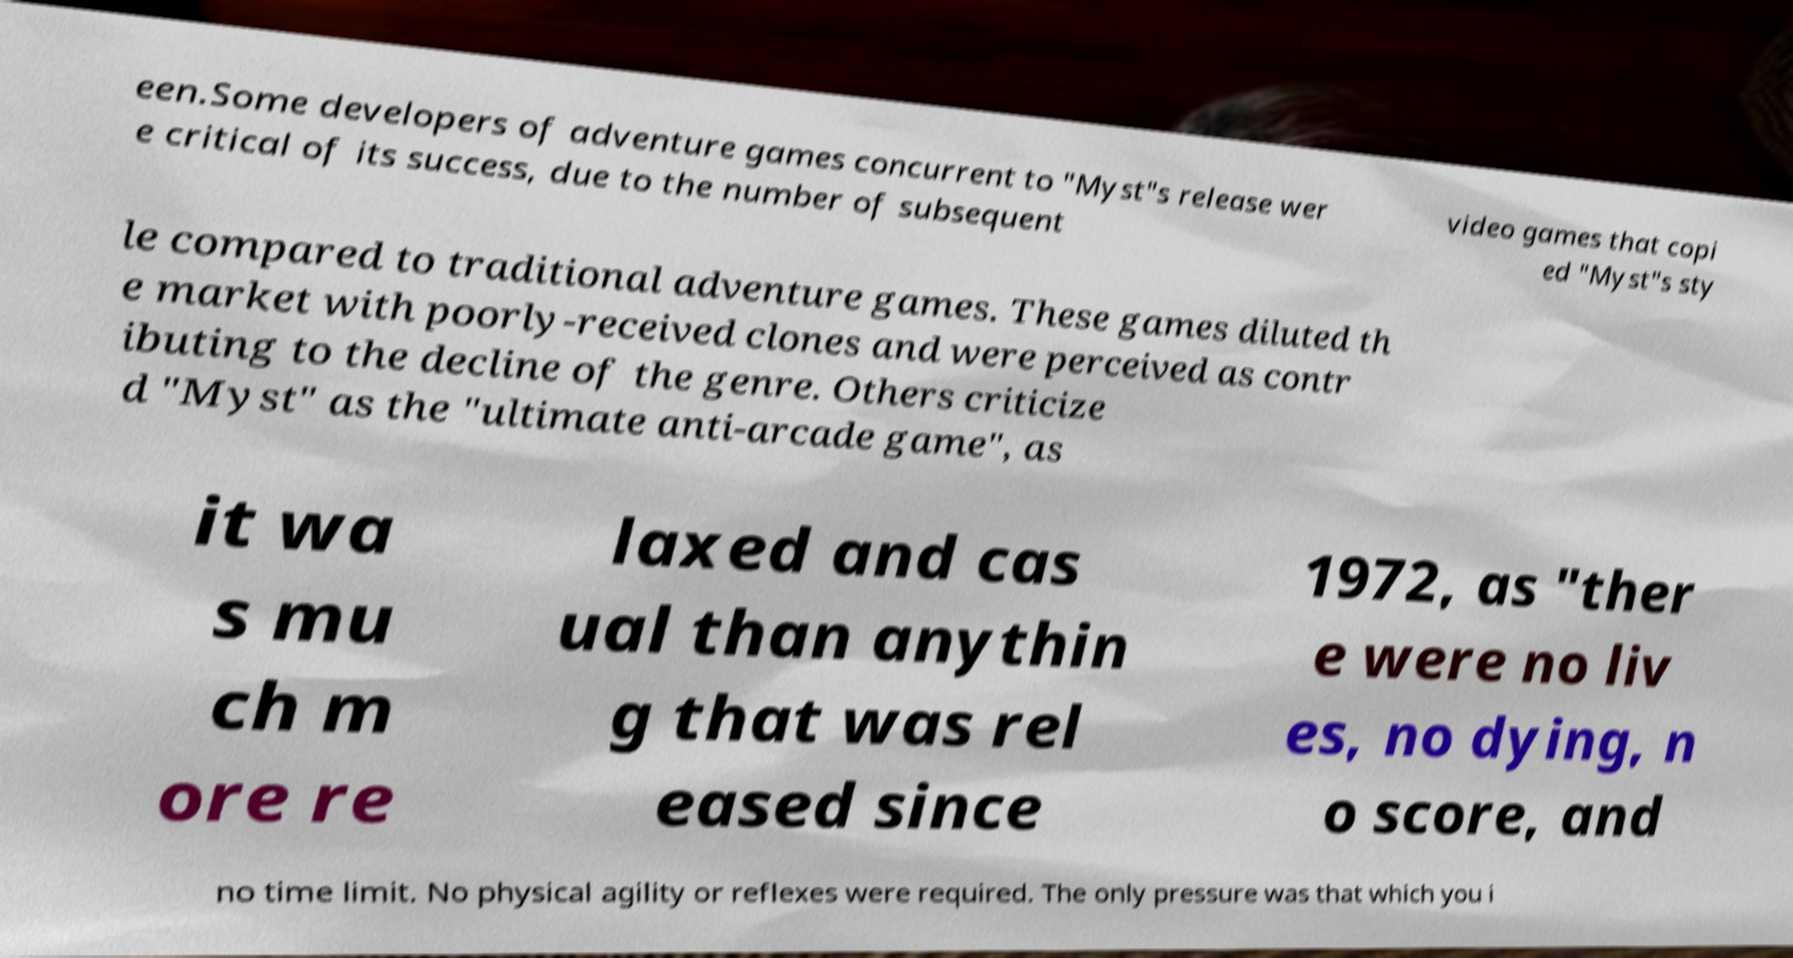Please read and relay the text visible in this image. What does it say? een.Some developers of adventure games concurrent to "Myst"s release wer e critical of its success, due to the number of subsequent video games that copi ed "Myst"s sty le compared to traditional adventure games. These games diluted th e market with poorly-received clones and were perceived as contr ibuting to the decline of the genre. Others criticize d "Myst" as the "ultimate anti-arcade game", as it wa s mu ch m ore re laxed and cas ual than anythin g that was rel eased since 1972, as "ther e were no liv es, no dying, n o score, and no time limit. No physical agility or reflexes were required. The only pressure was that which you i 